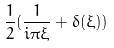Convert formula to latex. <formula><loc_0><loc_0><loc_500><loc_500>\frac { 1 } { 2 } ( \frac { 1 } { i \pi \xi } + \delta ( \xi ) )</formula> 